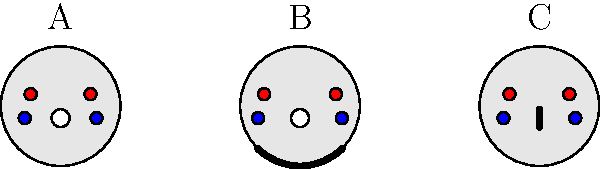Based on the cross-sectional diagrams of the neck shown above, which technique (B or C) represents a blood choke, and why is it generally considered more effective in MMA competitions? To answer this question, let's analyze the diagrams step-by-step:

1. Diagram A shows a normal neck cross-section with:
   - Two arteries (red circles) supplying blood to the brain
   - Two veins (blue circles) returning blood from the brain
   - Trachea (white circle) for air passage

2. Diagram B shows:
   - Pressure applied to both sides of the neck (thick curved lines)
   - This compression affects both arteries and veins

3. Diagram C shows:
   - Pressure applied directly to the trachea (thick vertical line)
   - Arteries and veins are not significantly affected

4. Blood choke (Diagram B):
   - Restricts blood flow to and from the brain
   - Can cause unconsciousness in 5-10 seconds
   - Less painful and doesn't rely on pain compliance

5. Air choke (Diagram C):
   - Restricts air flow through the trachea
   - Takes longer to cause unconsciousness (30+ seconds)
   - More painful and may trigger a stronger defensive response

6. In MMA competitions:
   - Quick submission is crucial
   - Opponents are trained to resist pain
   - Referees prioritize fighter safety

Therefore, Diagram B represents a blood choke, which is generally considered more effective in MMA because it works faster, is less dependent on pain tolerance, and is less likely to cause lasting damage.
Answer: B; faster unconsciousness, less pain-dependent 